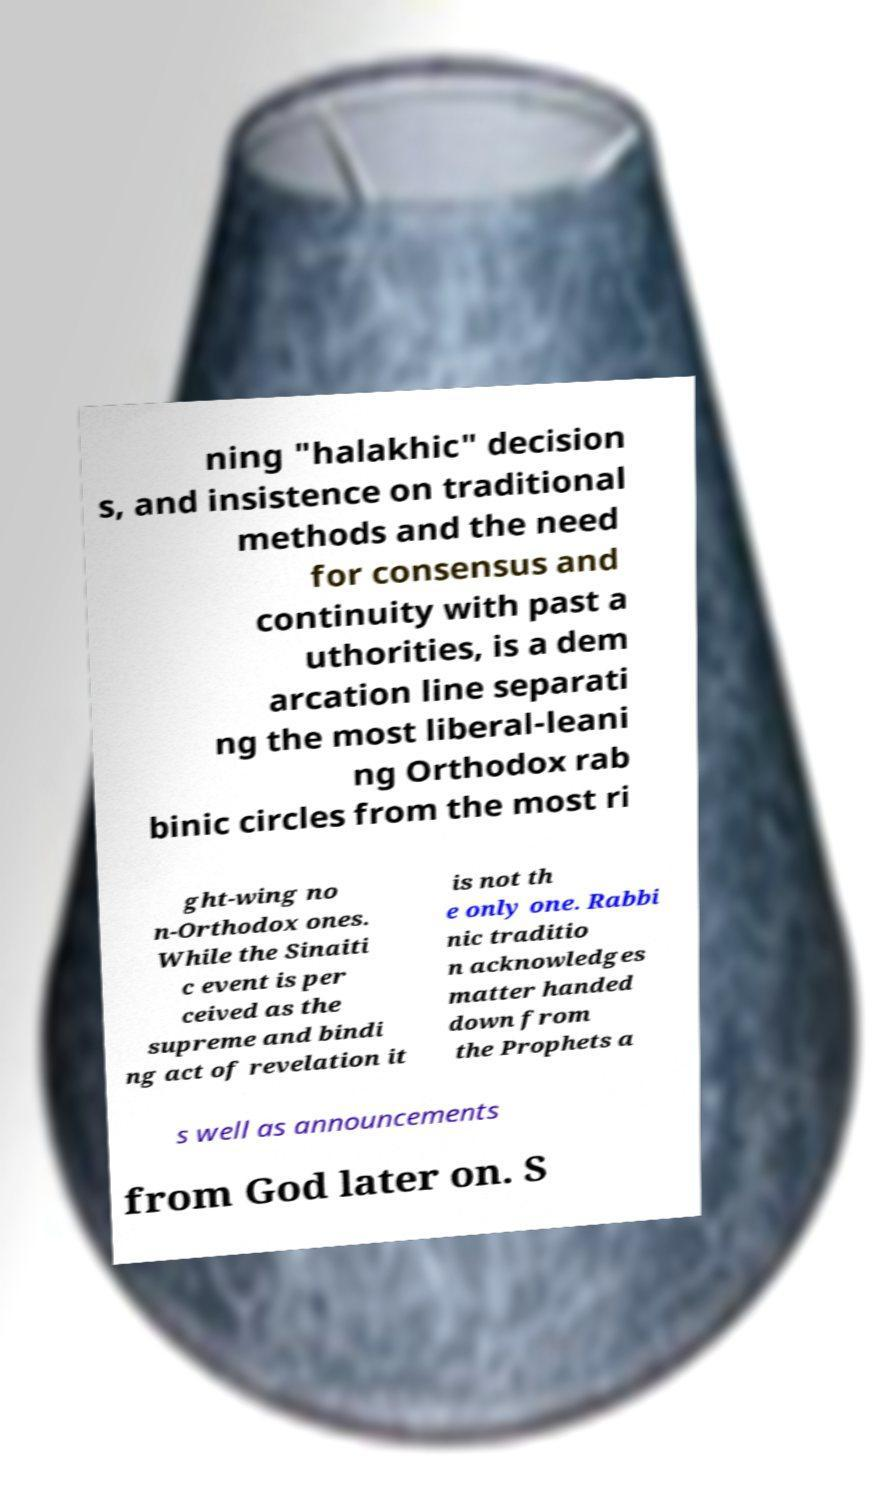Please read and relay the text visible in this image. What does it say? ning "halakhic" decision s, and insistence on traditional methods and the need for consensus and continuity with past a uthorities, is a dem arcation line separati ng the most liberal-leani ng Orthodox rab binic circles from the most ri ght-wing no n-Orthodox ones. While the Sinaiti c event is per ceived as the supreme and bindi ng act of revelation it is not th e only one. Rabbi nic traditio n acknowledges matter handed down from the Prophets a s well as announcements from God later on. S 